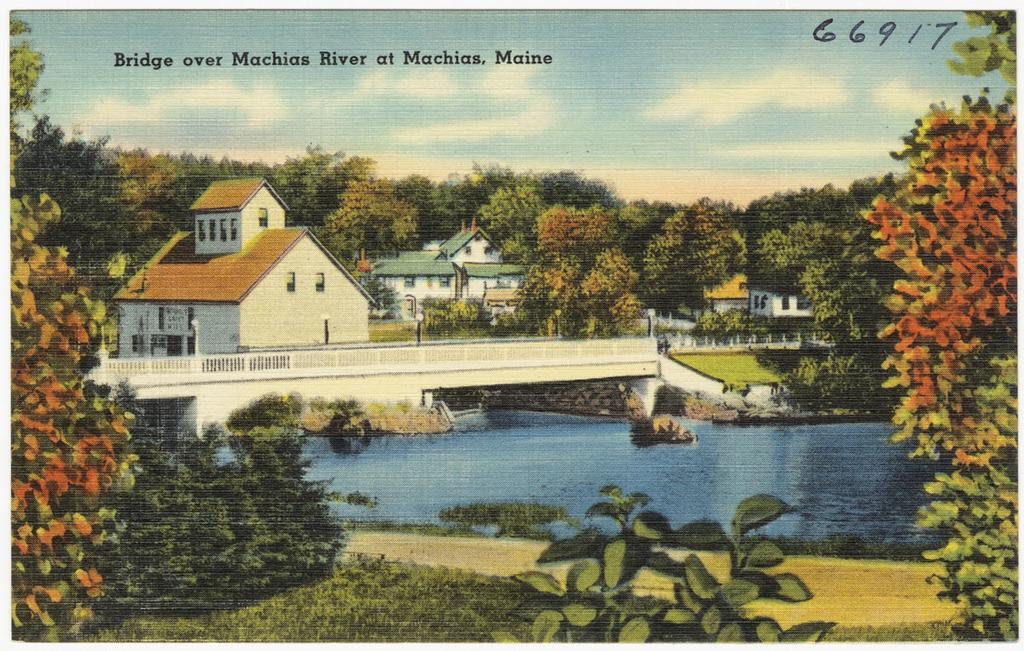What is depicted on the poster in the image? The poster contains houses, a bridge, railing, water, grass, plants, trees, clouds in the sky, and light poles. What type of environment is shown on the poster? The poster depicts a landscape with various elements such as water, grass, plants, trees, and a bridge. Are there any man-made structures on the poster? Yes, the poster contains houses and light poles. Is there any text written on the poster? Yes, there is text written on the poster. What type of cushion is used to support the flowers in the image? There are no cushions or flowers present in the image; it only contains a poster with various elements. 